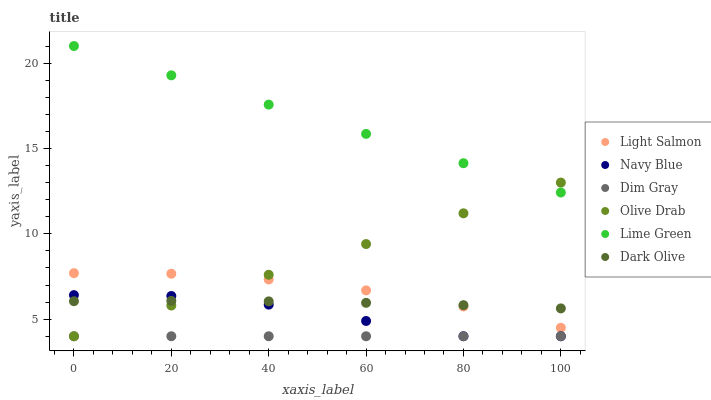Does Dim Gray have the minimum area under the curve?
Answer yes or no. Yes. Does Lime Green have the maximum area under the curve?
Answer yes or no. Yes. Does Navy Blue have the minimum area under the curve?
Answer yes or no. No. Does Navy Blue have the maximum area under the curve?
Answer yes or no. No. Is Dim Gray the smoothest?
Answer yes or no. Yes. Is Navy Blue the roughest?
Answer yes or no. Yes. Is Navy Blue the smoothest?
Answer yes or no. No. Is Dim Gray the roughest?
Answer yes or no. No. Does Dim Gray have the lowest value?
Answer yes or no. Yes. Does Dark Olive have the lowest value?
Answer yes or no. No. Does Lime Green have the highest value?
Answer yes or no. Yes. Does Navy Blue have the highest value?
Answer yes or no. No. Is Navy Blue less than Lime Green?
Answer yes or no. Yes. Is Dark Olive greater than Dim Gray?
Answer yes or no. Yes. Does Light Salmon intersect Dark Olive?
Answer yes or no. Yes. Is Light Salmon less than Dark Olive?
Answer yes or no. No. Is Light Salmon greater than Dark Olive?
Answer yes or no. No. Does Navy Blue intersect Lime Green?
Answer yes or no. No. 